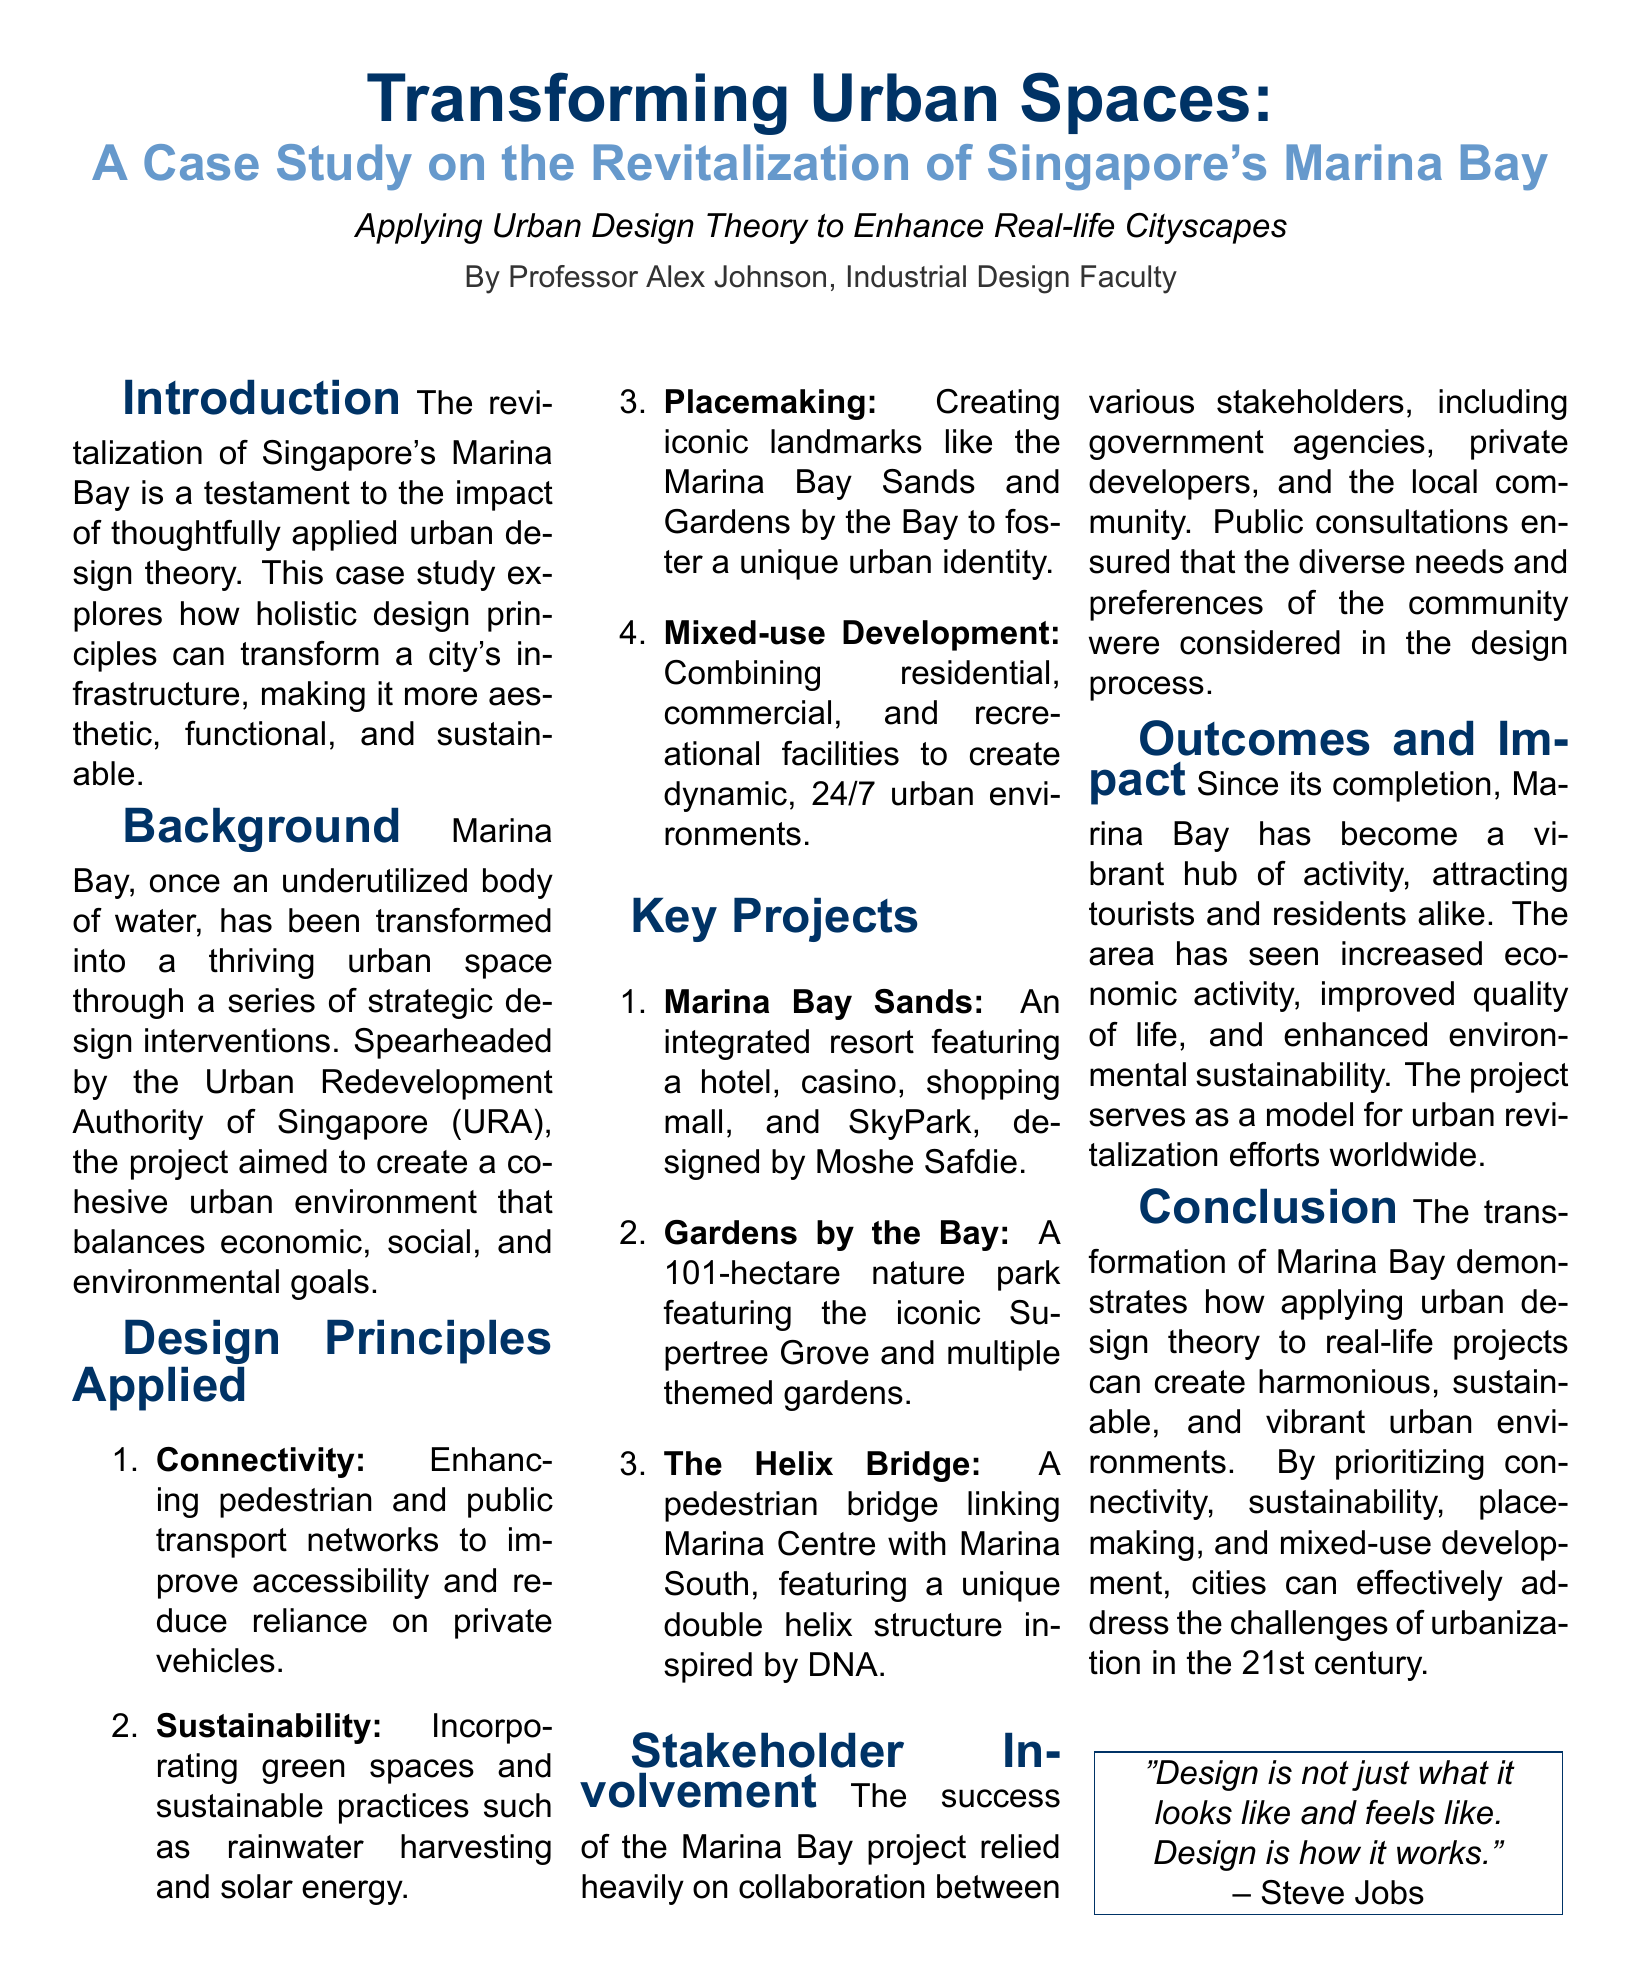What is the title of the case study? The title is prominently featured at the top of the document, which is "Transforming Urban Spaces."
Answer: Transforming Urban Spaces Who authored the case study? The author's name is mentioned in the document, specifically cited under the introduction section.
Answer: Professor Alex Johnson What type of design principle emphasizes pedestrian connectivity? The document lists several design principles, one of which emphasizes pedestrian connectivity.
Answer: Connectivity Which landmark is described as an integrated resort? The document details several key projects, explicitly naming one as an integrated resort.
Answer: Marina Bay Sands What year is the project considered a model for urban revitalization efforts? The outcomes and impact section reflects on the project serving as a model, indicating its successful implementation year.
Answer: 21st century What is the defining structure of The Helix Bridge? The document describes the distinctive design inspiration behind The Helix Bridge's structure.
Answer: Double helix structure How many hectares does Gardens by the Bay cover? The document specifies the area of Gardens by the Bay in its key projects section.
Answer: 101 hectares What is the central theme of the conclusion? The conclusion summarizes the core focus of the urban design theory applied to the project.
Answer: Sustainable urban environments 